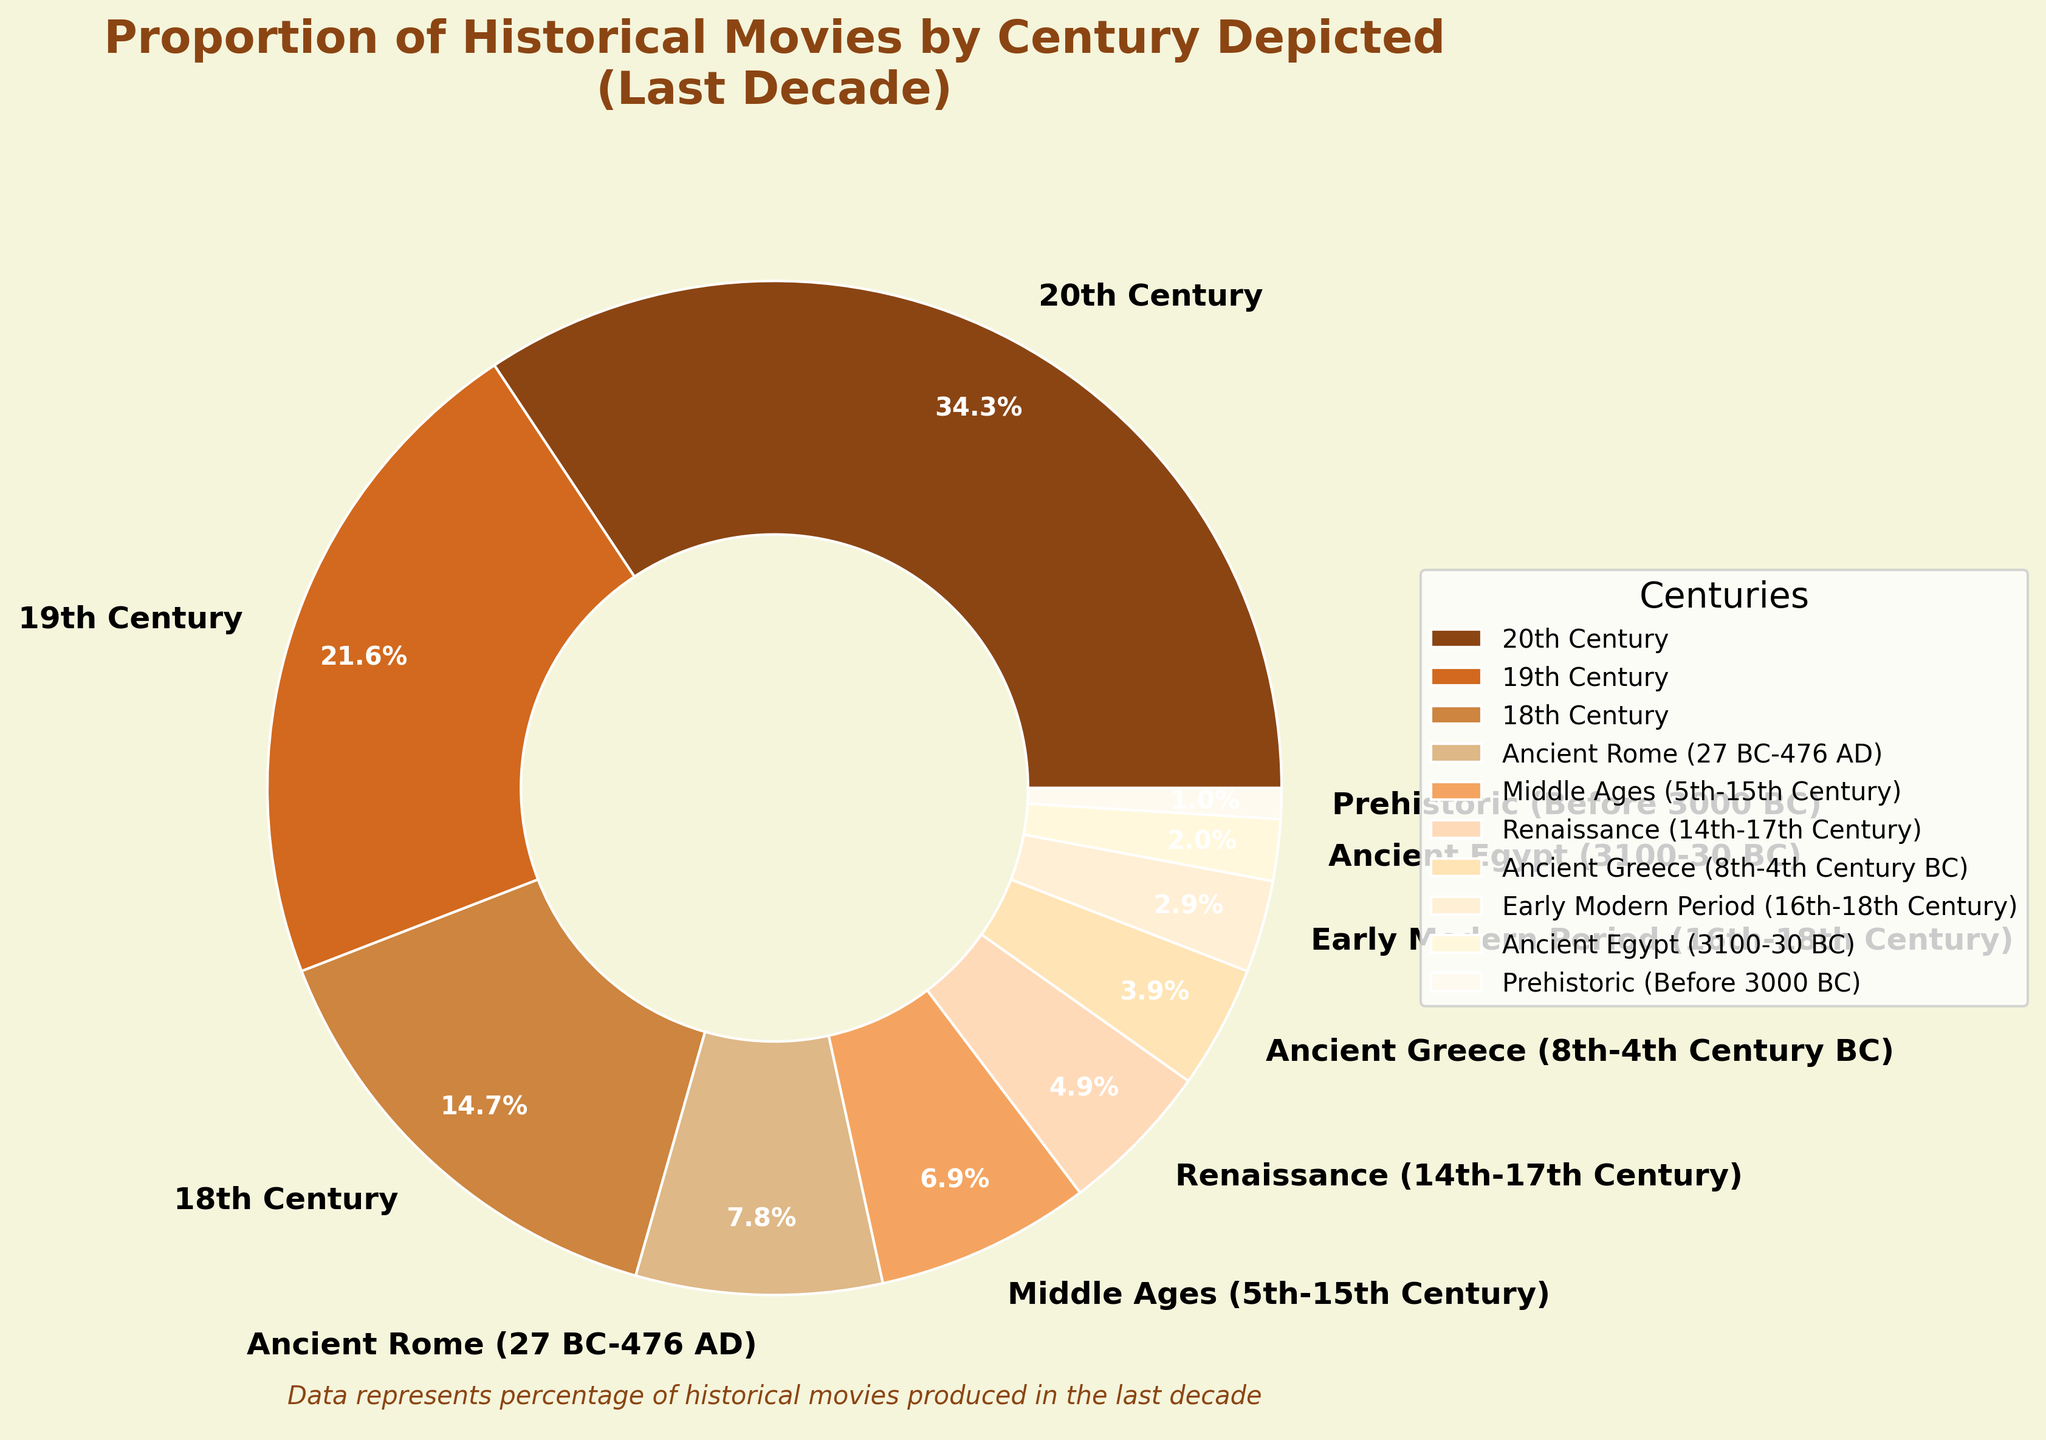Which century has the highest proportion of historical movies produced in the last decade? The 20th Century wedge occupies the largest area on the pie chart and is labeled with 35%.
Answer: 20th Century What is the combined percentage of movies depicting Ancient Rome and Ancient Greece? The percentage of Ancient Rome is 8% and Ancient Greece is 4%. Adding these together gives 8% + 4% = 12%.
Answer: 12% How does the proportion of movies depicting the 19th Century compare to those depicting the Early Modern Period? The 19th Century accounts for 22%, while the Early Modern Period accounts for 3%. Therefore, the 19th Century has a much larger proportion.
Answer: 19th Century has a larger proportion Which period has the lowest proportion, and what is it? The chart shows Prehistoric with the smallest wedge, indicating 1% of produced movies.
Answer: Prehistoric, 1% What is the proportion of movies depicting centuries prior to the 18th Century combined? Combining the percentages of Ancient Rome (8%), Middle Ages (7%), Renaissance (5%), Ancient Greece (4%), Early Modern Period (3%), Ancient Egypt (2%), and Prehistoric (1%) gives: 8% + 7% + 5% + 4% + 3% + 2% + 1% = 30%.
Answer: 30% Compare the proportions of movies depicting the Middle Ages versus the Renaissance. The Middle Ages have a proportion of 7%, while the Renaissance has 5%. Thus, the Middle Ages are depicted more frequently than the Renaissance.
Answer: Middle Ages more frequent How much more frequent are movies set in the 20th Century compared to those set in Ancient Egypt? The 20th Century has 35%, and Ancient Egypt has 2%. The difference is 35% - 2% = 33%.
Answer: 33% What is the average proportion of the three most frequently depicted centuries? The three most frequently depicted centuries are the 20th Century (35%), 19th Century (22%), and 18th Century (15%). The average is (35% + 22% + 15%) / 3 = 24%.
Answer: 24% What century ranks third in terms of the proportion of historical movies depicted? The chart shows the 18th Century at 15%, which is the third highest proportion after the 20th Century and 19th Century.
Answer: 18th Century How does the percentage of movies set in the Middle Ages compare to those set in the 19th Century? The Middle Ages have 7%, while the 19th Century has 22%. The 19th Century has a larger proportion of movies.
Answer: 19th Century has a larger proportion 